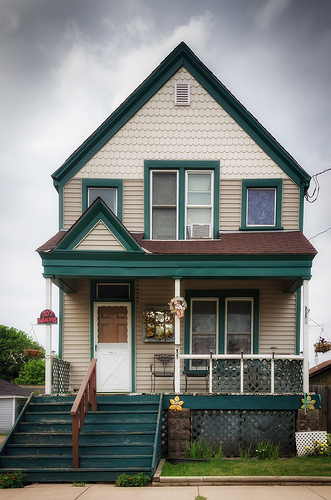<image>
Is the decoration on the pole? No. The decoration is not positioned on the pole. They may be near each other, but the decoration is not supported by or resting on top of the pole. Is the flower in front of the house? Yes. The flower is positioned in front of the house, appearing closer to the camera viewpoint. 